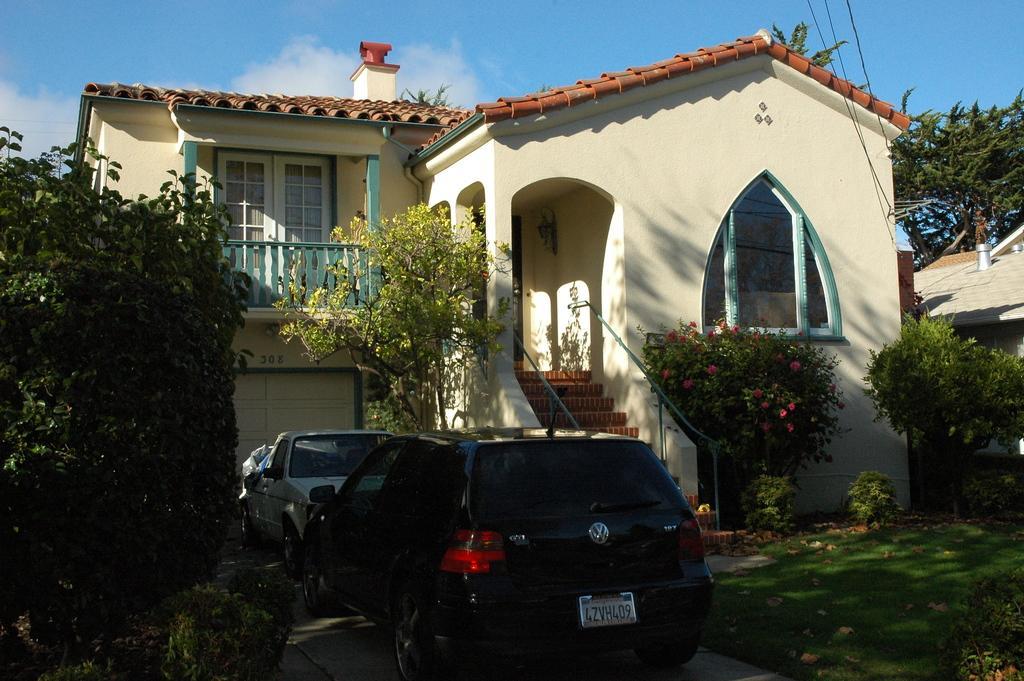Could you give a brief overview of what you see in this image? In this picture I can see houses in front we can see two vehicles are packed, around we can see some flowers to the plants, trees and grass. 